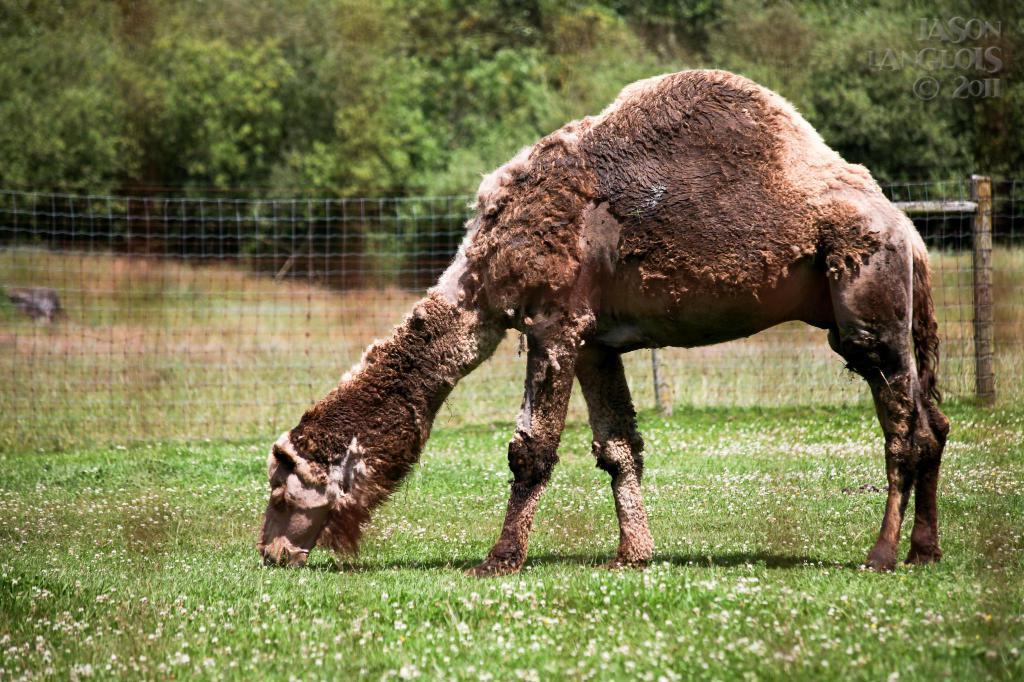In one or two sentences, can you explain what this image depicts? There is an animal in the foreground area of the image, there are trees and a net fencing in the background. 